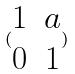<formula> <loc_0><loc_0><loc_500><loc_500>( \begin{matrix} 1 & a \\ 0 & 1 \end{matrix} )</formula> 